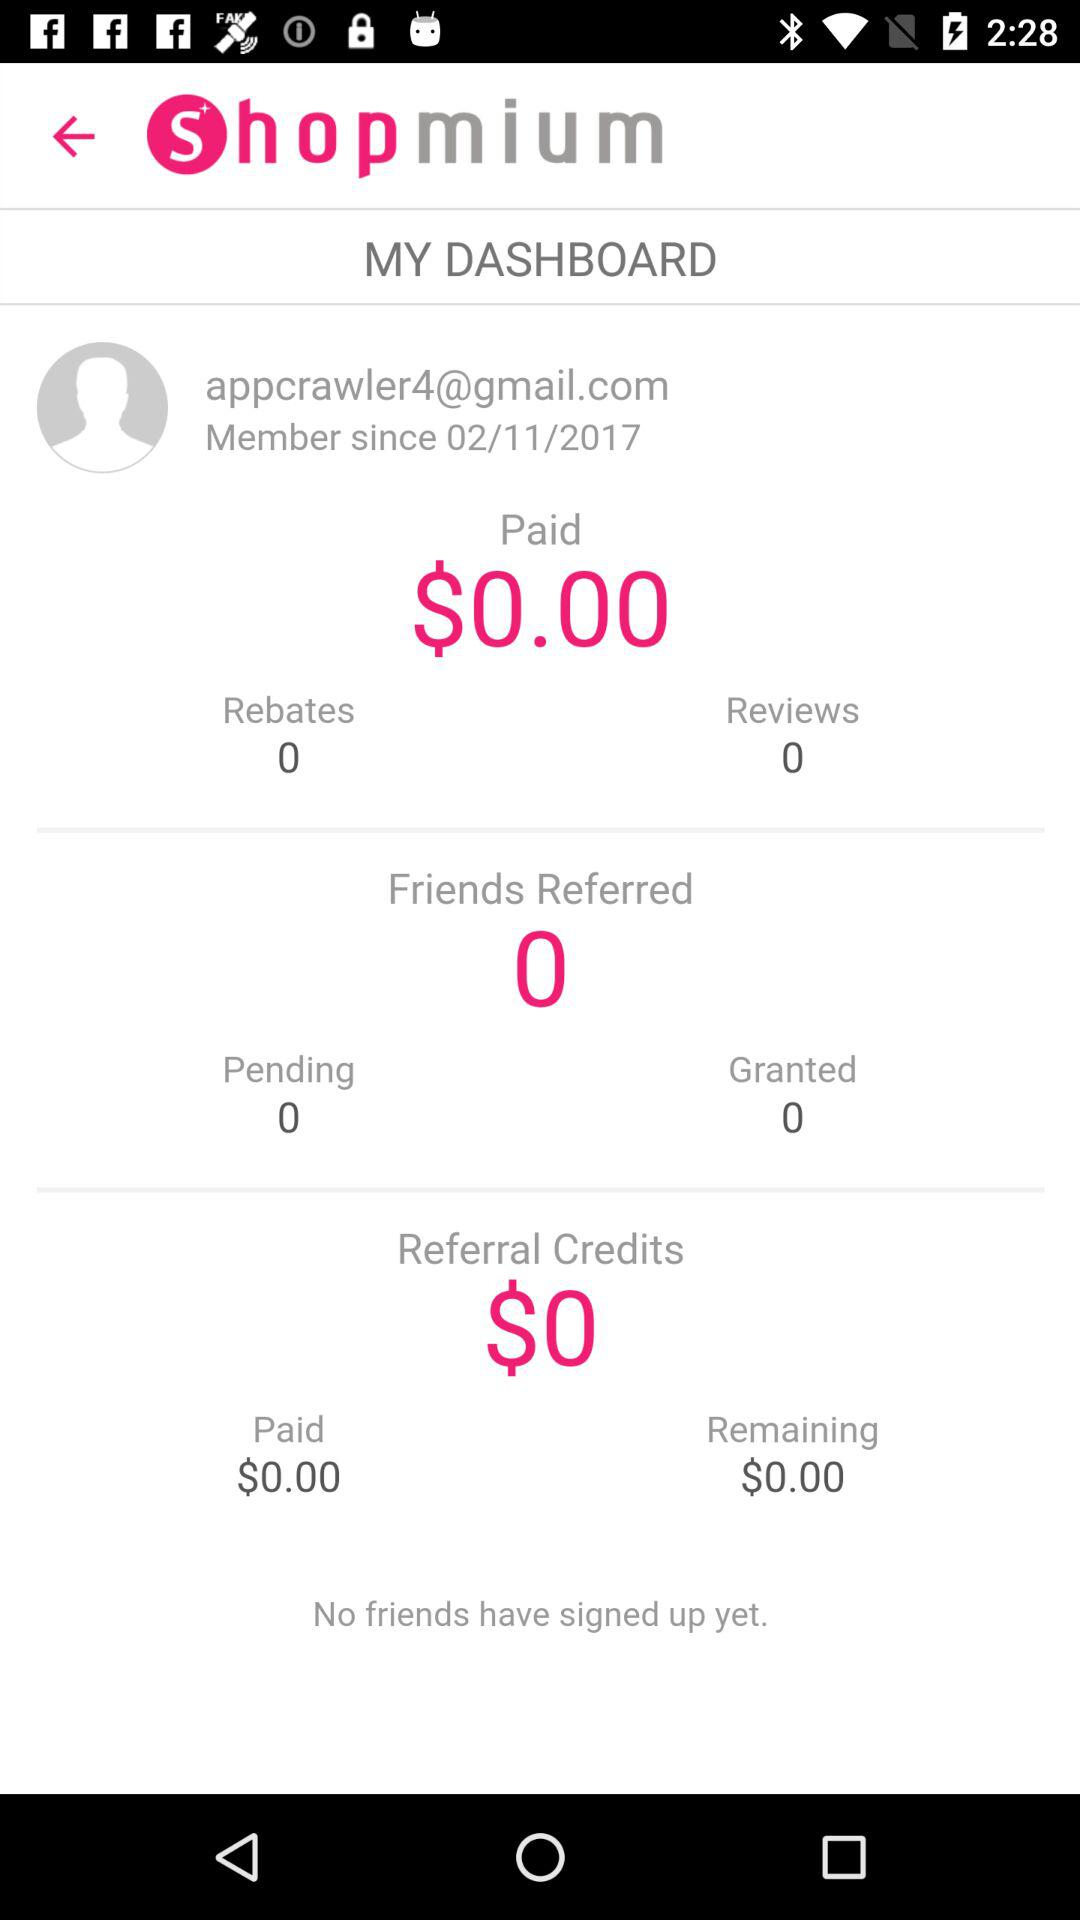What is the name of the application? The name of the application is "Shopmium". 